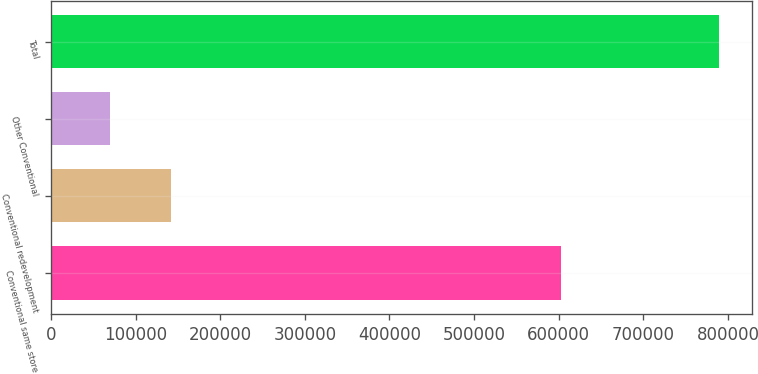Convert chart. <chart><loc_0><loc_0><loc_500><loc_500><bar_chart><fcel>Conventional same store<fcel>Conventional redevelopment<fcel>Other Conventional<fcel>Total<nl><fcel>602960<fcel>141617<fcel>69662<fcel>789210<nl></chart> 